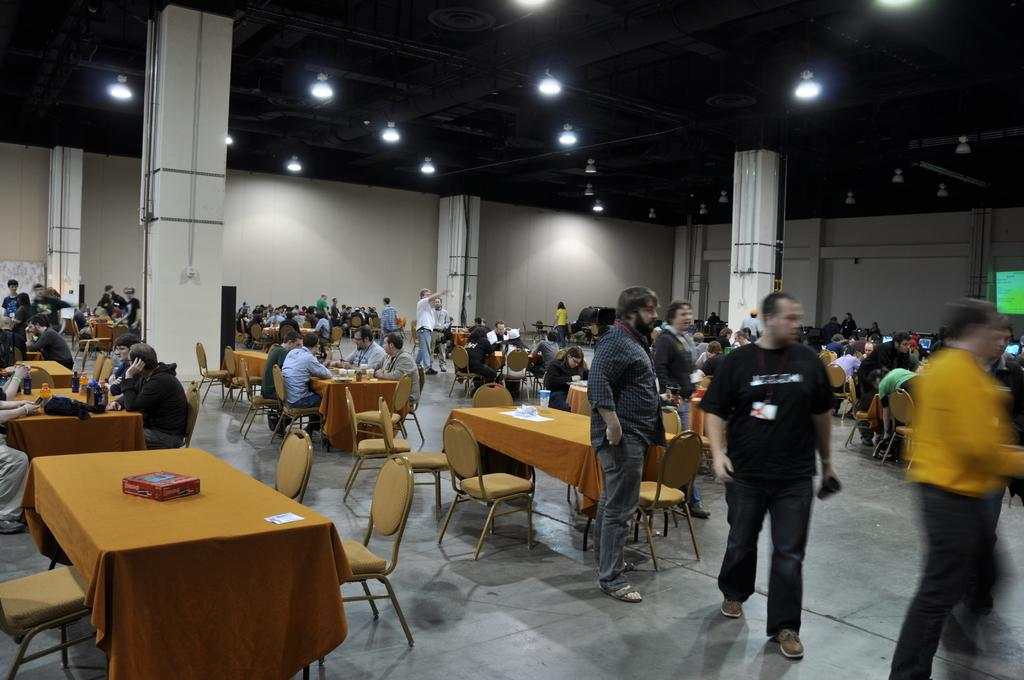What is the main subject of the image? The main subject of the image is a group of guys. What are the guys in the image doing? The guys are sitting on chairs and standing in the image. What is in front of the chairs? There are tables in front of the chairs. What can be seen at the top of the image? There are lights at the top of the image. What type of cable can be seen connecting the guys in the image? There is no cable connecting the guys in the image. How many sisters are present in the image? There is no mention of sisters in the image; it features a group of guys. 